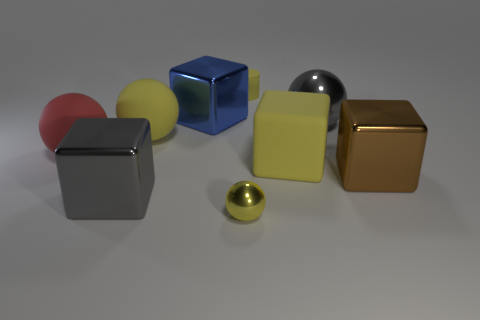How do the different textures of the objects contribute to the overall feel of the image? The juxtaposition of the smooth spheres and the more textured cubes creates an interesting visual dynamic. It reflects the diversity and contrast that textures can bring to a composition, enhancing its aesthetic appeal. 